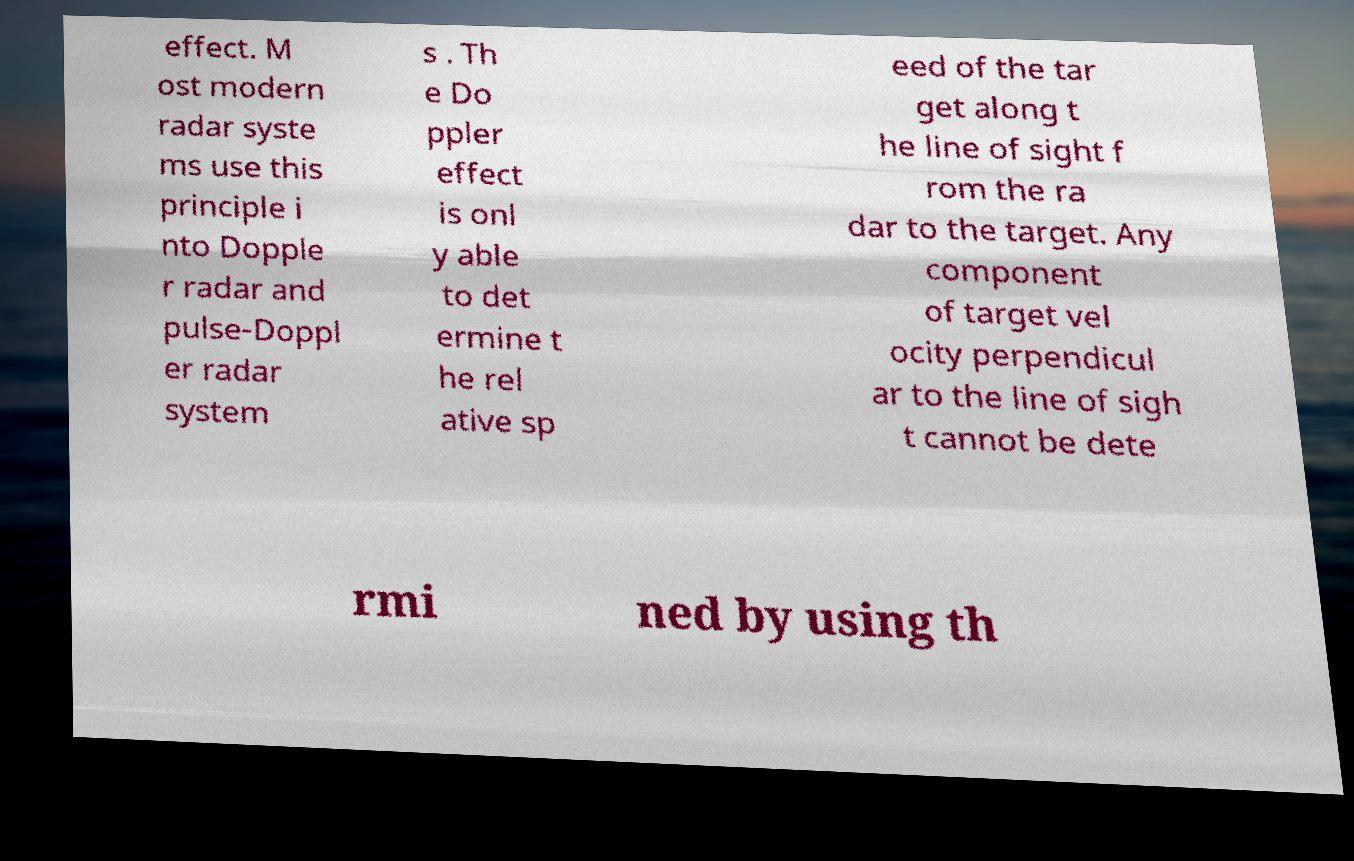Please read and relay the text visible in this image. What does it say? effect. M ost modern radar syste ms use this principle i nto Dopple r radar and pulse-Doppl er radar system s . Th e Do ppler effect is onl y able to det ermine t he rel ative sp eed of the tar get along t he line of sight f rom the ra dar to the target. Any component of target vel ocity perpendicul ar to the line of sigh t cannot be dete rmi ned by using th 